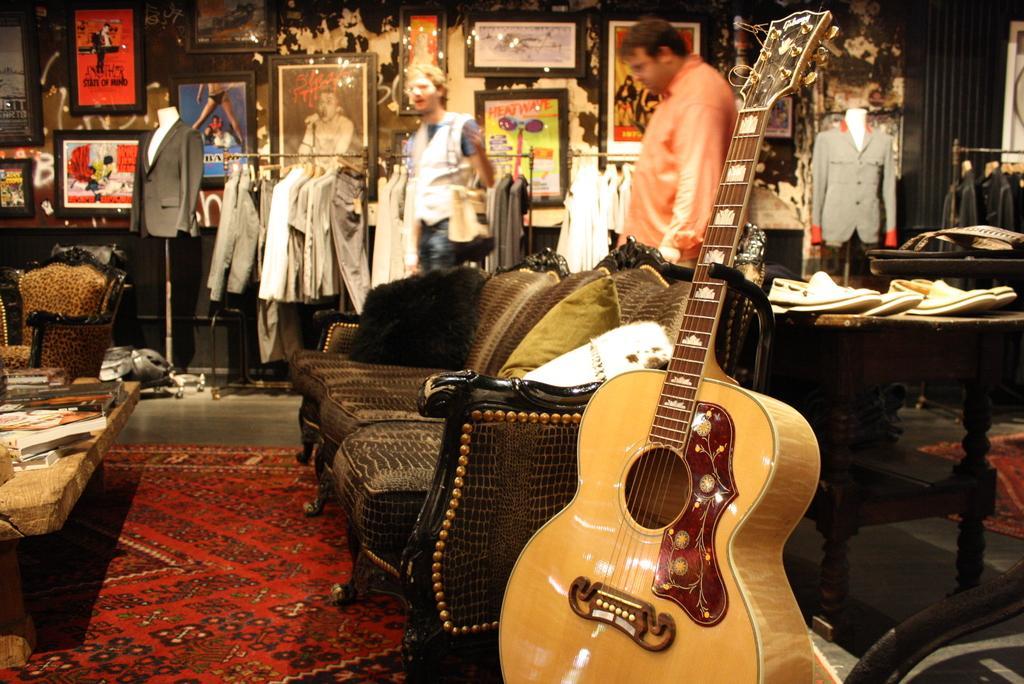In one or two sentences, can you explain what this image depicts? There is a brown sofa which has a guitar beside it and there are some dresses on the other side of the sofa and there are two persons behind the sofa. 